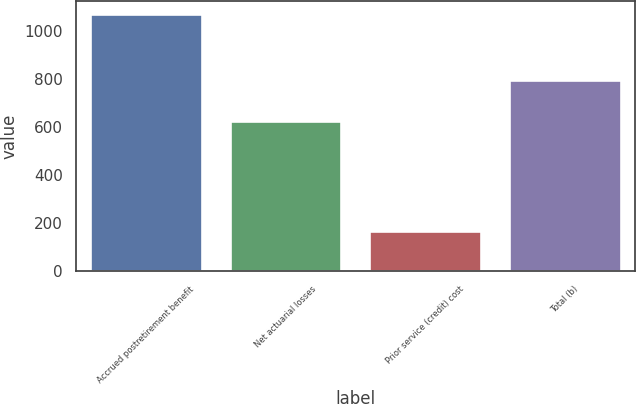Convert chart. <chart><loc_0><loc_0><loc_500><loc_500><bar_chart><fcel>Accrued postretirement benefit<fcel>Net actuarial losses<fcel>Prior service (credit) cost<fcel>Total (b)<nl><fcel>1070<fcel>627<fcel>167<fcel>794<nl></chart> 